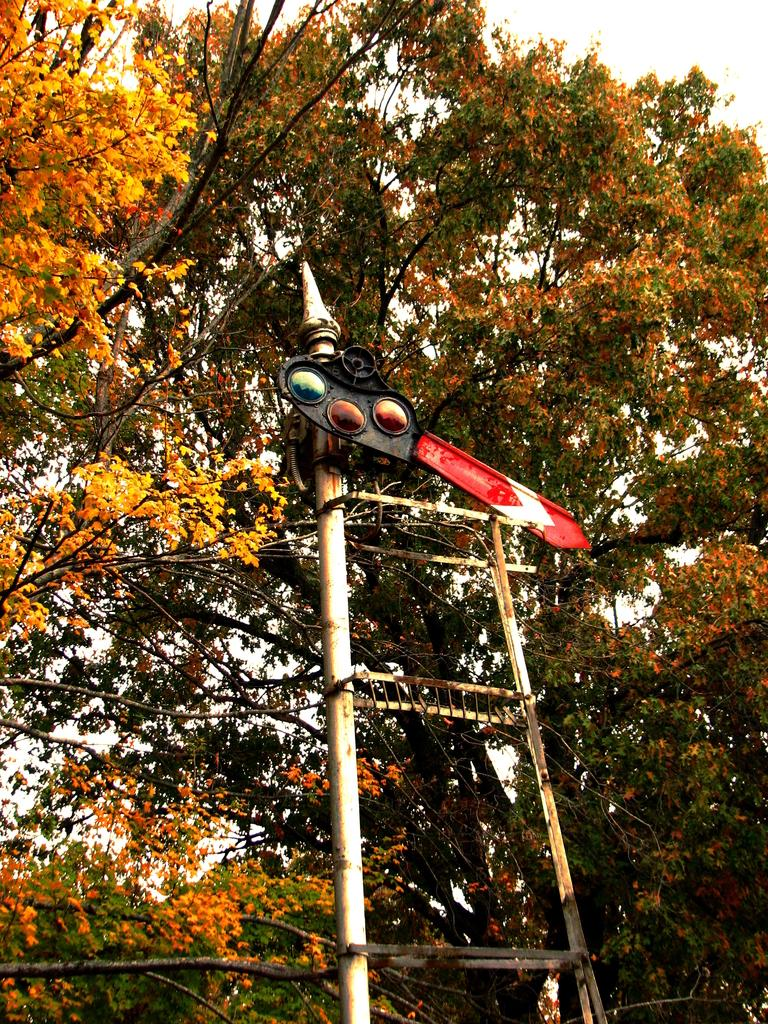What is the main object in the image? There is a pole in the image. What can be seen in the background of the image? There are trees in the background of the image. What type of pancake is being served on the pole in the image? There is no pancake present in the image; it only features a pole and trees in the background. 